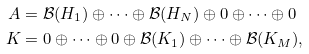<formula> <loc_0><loc_0><loc_500><loc_500>A & = \mathcal { B } ( H _ { 1 } ) \oplus \cdots \oplus \mathcal { B } ( H _ { N } ) \oplus 0 \oplus \cdots \oplus 0 \\ K & = 0 \oplus \cdots \oplus 0 \oplus \mathcal { B } ( K _ { 1 } ) \oplus \cdots \oplus \mathcal { B } ( K _ { M } ) ,</formula> 